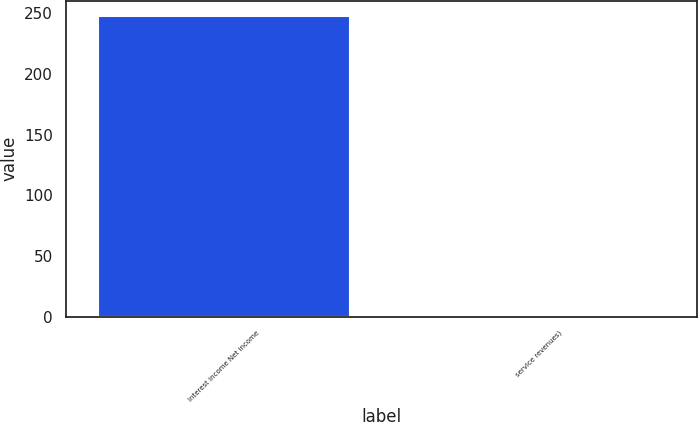Convert chart. <chart><loc_0><loc_0><loc_500><loc_500><bar_chart><fcel>Interest income Net income<fcel>service revenues)<nl><fcel>248<fcel>1<nl></chart> 